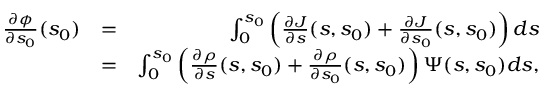Convert formula to latex. <formula><loc_0><loc_0><loc_500><loc_500>\begin{array} { r l r } { \frac { \partial \phi } { \partial s _ { 0 } } ( s _ { 0 } ) } & { = } & { \int _ { 0 } ^ { s _ { 0 } } \left ( \frac { \partial J } { \partial s } ( s , s _ { 0 } ) + \frac { \partial J } { \partial s _ { 0 } } ( s , s _ { 0 } ) \right ) d s } \\ & { = } & { \int _ { 0 } ^ { s _ { 0 } } \left ( \frac { \partial \rho } { \partial s } ( s , s _ { 0 } ) + \frac { \partial \rho } { \partial s _ { 0 } } ( s , s _ { 0 } ) \right ) \Psi ( s , s _ { 0 } ) d s , } \end{array}</formula> 